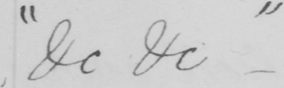What does this handwritten line say? " &c &c " 